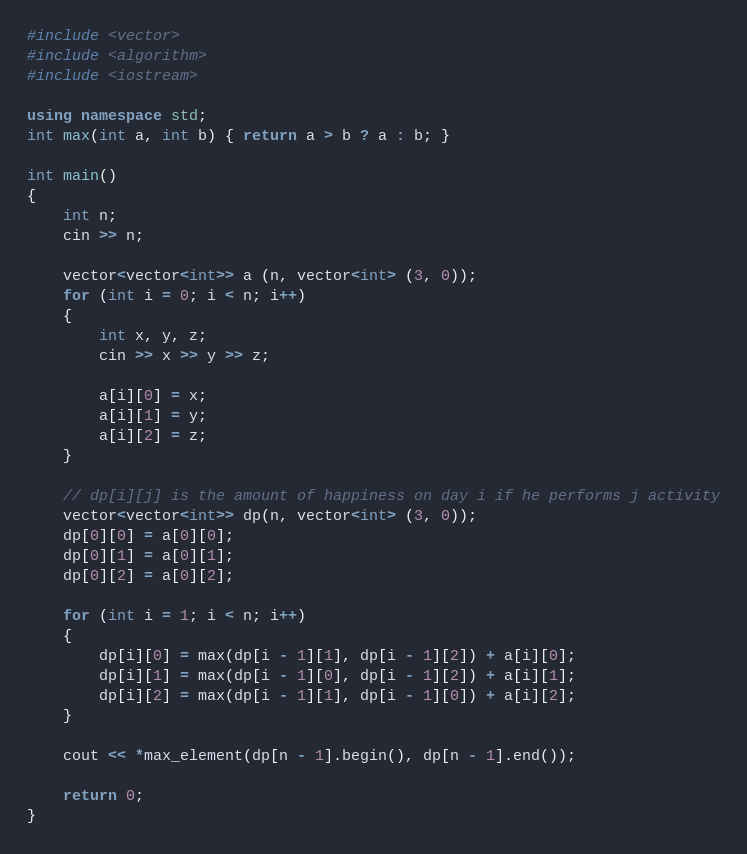Convert code to text. <code><loc_0><loc_0><loc_500><loc_500><_C++_>#include <vector>
#include <algorithm>
#include <iostream>

using namespace std;
int max(int a, int b) { return a > b ? a : b; }

int main()
{
    int n;
    cin >> n;

    vector<vector<int>> a (n, vector<int> (3, 0));
    for (int i = 0; i < n; i++)
    {
        int x, y, z;
        cin >> x >> y >> z;

        a[i][0] = x;
        a[i][1] = y;
        a[i][2] = z;
    }

    // dp[i][j] is the amount of happiness on day i if he performs j activity
    vector<vector<int>> dp(n, vector<int> (3, 0));
    dp[0][0] = a[0][0];
    dp[0][1] = a[0][1];
    dp[0][2] = a[0][2];

    for (int i = 1; i < n; i++)
    {
        dp[i][0] = max(dp[i - 1][1], dp[i - 1][2]) + a[i][0];
        dp[i][1] = max(dp[i - 1][0], dp[i - 1][2]) + a[i][1];
        dp[i][2] = max(dp[i - 1][1], dp[i - 1][0]) + a[i][2];
    }

    cout << *max_element(dp[n - 1].begin(), dp[n - 1].end());

    return 0;
}</code> 